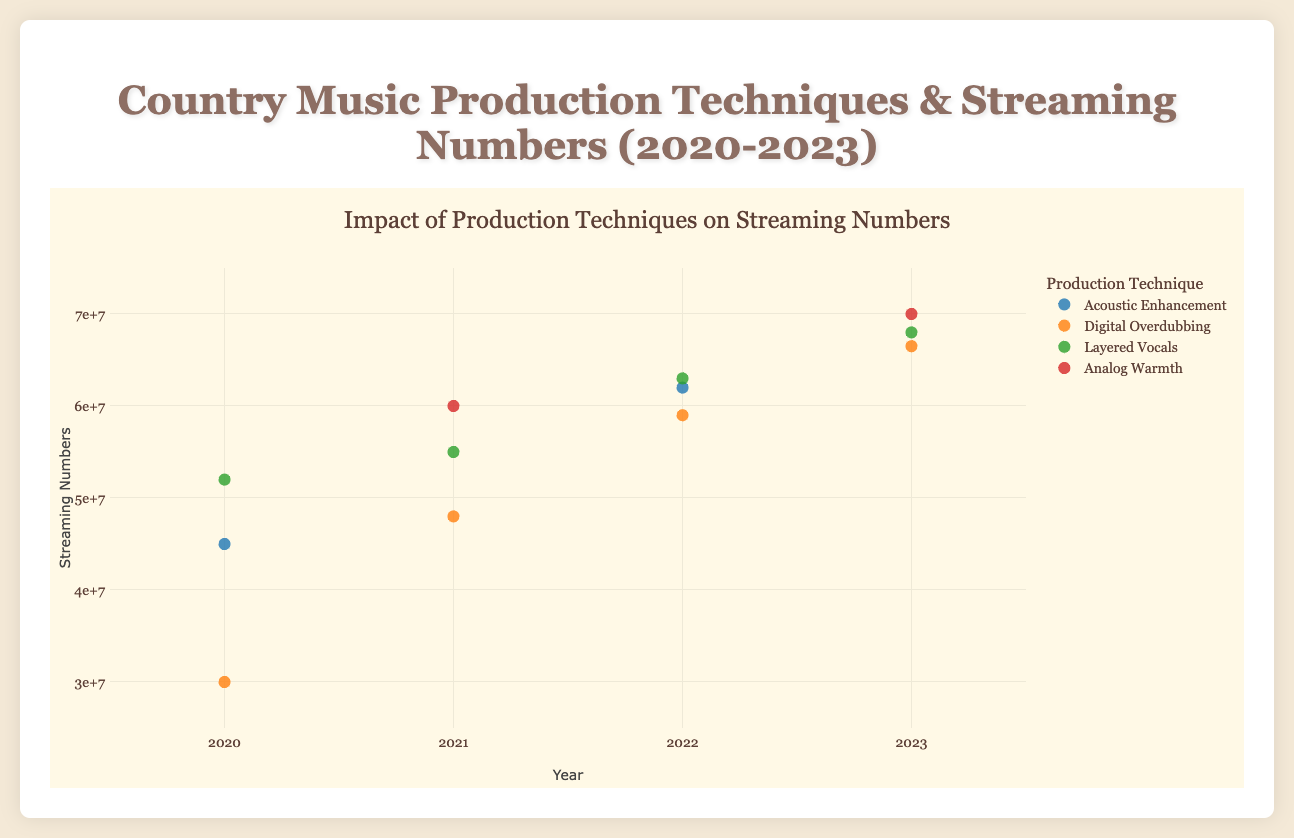What production technique was used for the song with the highest streaming numbers in 2023? Filtering the data to 2023, the highest streaming numbers were 70,000,000 for “Down to Earth.” The production technique for this song was "Analog Warmth".
Answer: Analog Warmth How many different production techniques are represented in the plot? Inspecting the legend of the plot, the different production techniques represented are displayed: Acoustic Enhancement, Digital Overdubbing, Layered Vocals, Analog Warmth. Counting these gives four production techniques.
Answer: Four What is the trend in streaming numbers for Michael Lee’s songs from 2020 to 2023? Observing the scatter plot data points for Michael Lee from 2020 (52,000,000), 2021 (55,000,000), 2022 (63,000,000), and 2023 (68,000,000), the streaming numbers show a consistent increase every year.
Answer: Increasing Which year had the highest total streaming numbers when considering all songs? Summing up the total streaming numbers for each year and comparing them: 2020 (127,000,000), 2021 (163,000,000), 2022 (184,000,000), and 2023 (204,500,000). The year 2023 has the highest total streaming numbers.
Answer: 2023 For 2021, which production technique had the highest average streaming numbers? Identifying the streaming numbers in 2021 for each technique: Analog Warmth (60,000,000), Digital Overdubbing (48,000,000), Layered Vocals (55,000,000), and calculating the averages: Analog Warmth (60,000,000), Digital Overdubbing (48,000,000), Layered Vocals (55,000,000). Analog Warmth has the highest average.
Answer: Analog Warmth Comparing "Digital Overdubbing" and "Layered Vocals," which technique has more consistent streaming numbers year over year? Reviewing the fluctuations between years for each: Digital Overdubbing (30,000,000, 48,000,000, 59,000,000, 66,500,000) shows more variability than Layered Vocals (52,000,000, 55,000,000, 63,000,000, 68,000,000), which consistently increases.
Answer: Layered Vocals In 2020, what was the total streaming number for the songs using the "Digital Overdubbing" technique? Looking at the data for 2020, only one song, "Heartland Melody," used the "Digital Overdubbing" technique with a streaming number of 30,000,000. Summing up, the total is 30,000,000.
Answer: 30,000,000 What production technique is most frequently used by the producer John Smith over the years? Listing John Smith’s production techniques from the data: Acoustic Enhancement (2020, 2022), Analog Warmth (2021, 2023). Counting the occurrences, both techniques are used twice, making them equally frequent.
Answer: Acoustic Enhancement and Analog Warmth (Tie) 